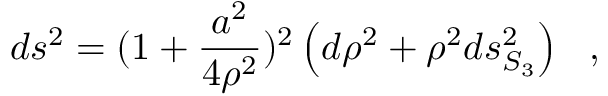<formula> <loc_0><loc_0><loc_500><loc_500>d s ^ { 2 } = ( 1 + { \frac { a ^ { 2 } } { 4 \rho ^ { 2 } } } ) ^ { 2 } \left ( d \rho ^ { 2 } + \rho ^ { 2 } d s _ { S _ { 3 } } ^ { 2 } \right ) ,</formula> 